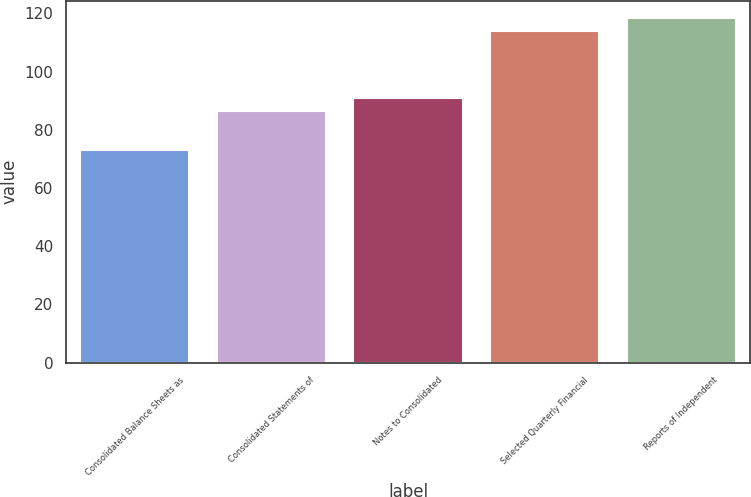Convert chart to OTSL. <chart><loc_0><loc_0><loc_500><loc_500><bar_chart><fcel>Consolidated Balance Sheets as<fcel>Consolidated Statements of<fcel>Notes to Consolidated<fcel>Selected Quarterly Financial<fcel>Reports of Independent<nl><fcel>73<fcel>86.5<fcel>91<fcel>114<fcel>118.5<nl></chart> 